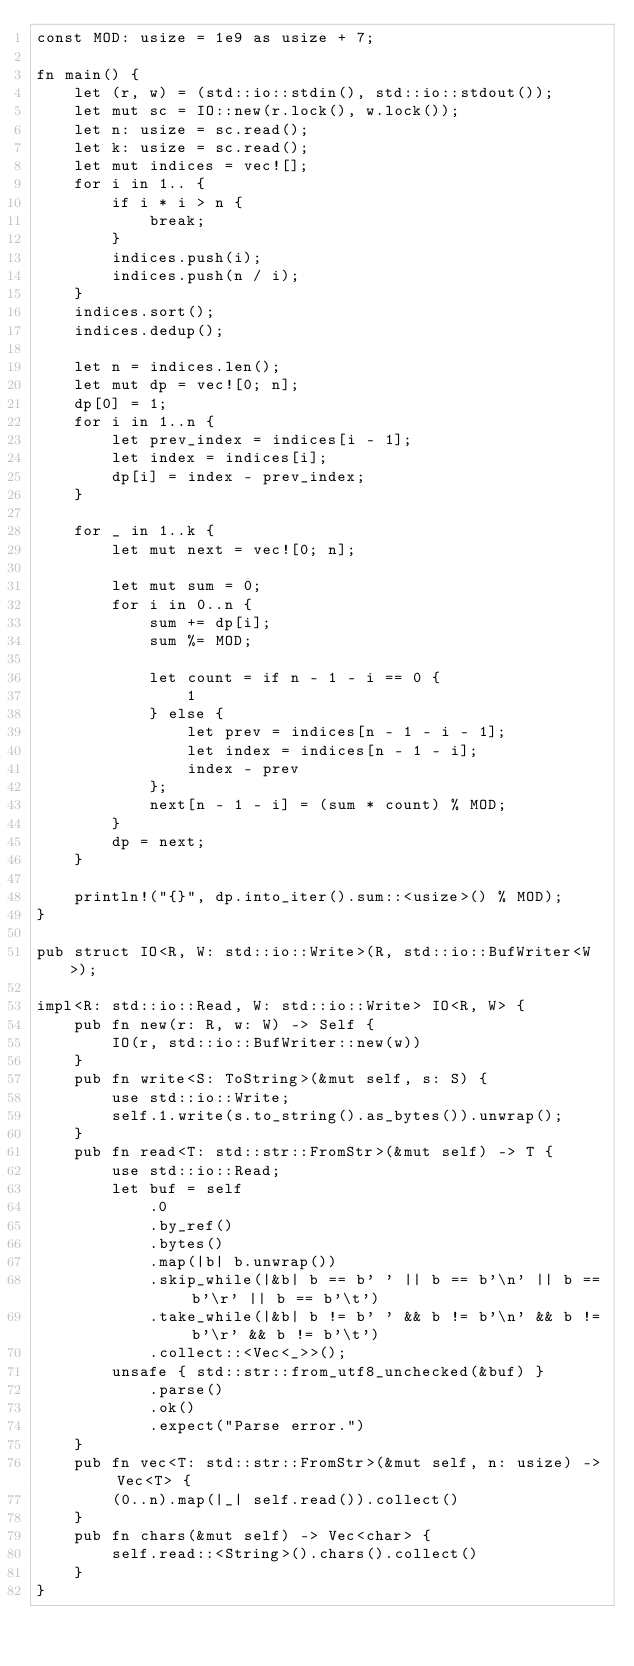Convert code to text. <code><loc_0><loc_0><loc_500><loc_500><_Rust_>const MOD: usize = 1e9 as usize + 7;

fn main() {
    let (r, w) = (std::io::stdin(), std::io::stdout());
    let mut sc = IO::new(r.lock(), w.lock());
    let n: usize = sc.read();
    let k: usize = sc.read();
    let mut indices = vec![];
    for i in 1.. {
        if i * i > n {
            break;
        }
        indices.push(i);
        indices.push(n / i);
    }
    indices.sort();
    indices.dedup();

    let n = indices.len();
    let mut dp = vec![0; n];
    dp[0] = 1;
    for i in 1..n {
        let prev_index = indices[i - 1];
        let index = indices[i];
        dp[i] = index - prev_index;
    }

    for _ in 1..k {
        let mut next = vec![0; n];

        let mut sum = 0;
        for i in 0..n {
            sum += dp[i];
            sum %= MOD;

            let count = if n - 1 - i == 0 {
                1
            } else {
                let prev = indices[n - 1 - i - 1];
                let index = indices[n - 1 - i];
                index - prev
            };
            next[n - 1 - i] = (sum * count) % MOD;
        }
        dp = next;
    }

    println!("{}", dp.into_iter().sum::<usize>() % MOD);
}

pub struct IO<R, W: std::io::Write>(R, std::io::BufWriter<W>);

impl<R: std::io::Read, W: std::io::Write> IO<R, W> {
    pub fn new(r: R, w: W) -> Self {
        IO(r, std::io::BufWriter::new(w))
    }
    pub fn write<S: ToString>(&mut self, s: S) {
        use std::io::Write;
        self.1.write(s.to_string().as_bytes()).unwrap();
    }
    pub fn read<T: std::str::FromStr>(&mut self) -> T {
        use std::io::Read;
        let buf = self
            .0
            .by_ref()
            .bytes()
            .map(|b| b.unwrap())
            .skip_while(|&b| b == b' ' || b == b'\n' || b == b'\r' || b == b'\t')
            .take_while(|&b| b != b' ' && b != b'\n' && b != b'\r' && b != b'\t')
            .collect::<Vec<_>>();
        unsafe { std::str::from_utf8_unchecked(&buf) }
            .parse()
            .ok()
            .expect("Parse error.")
    }
    pub fn vec<T: std::str::FromStr>(&mut self, n: usize) -> Vec<T> {
        (0..n).map(|_| self.read()).collect()
    }
    pub fn chars(&mut self) -> Vec<char> {
        self.read::<String>().chars().collect()
    }
}
</code> 